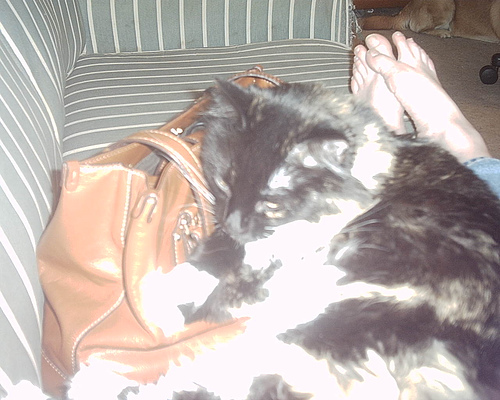Where does the cat rest?
A. dog house
B. cat house
C. couch
D. mattress The cat is resting on the couch. 